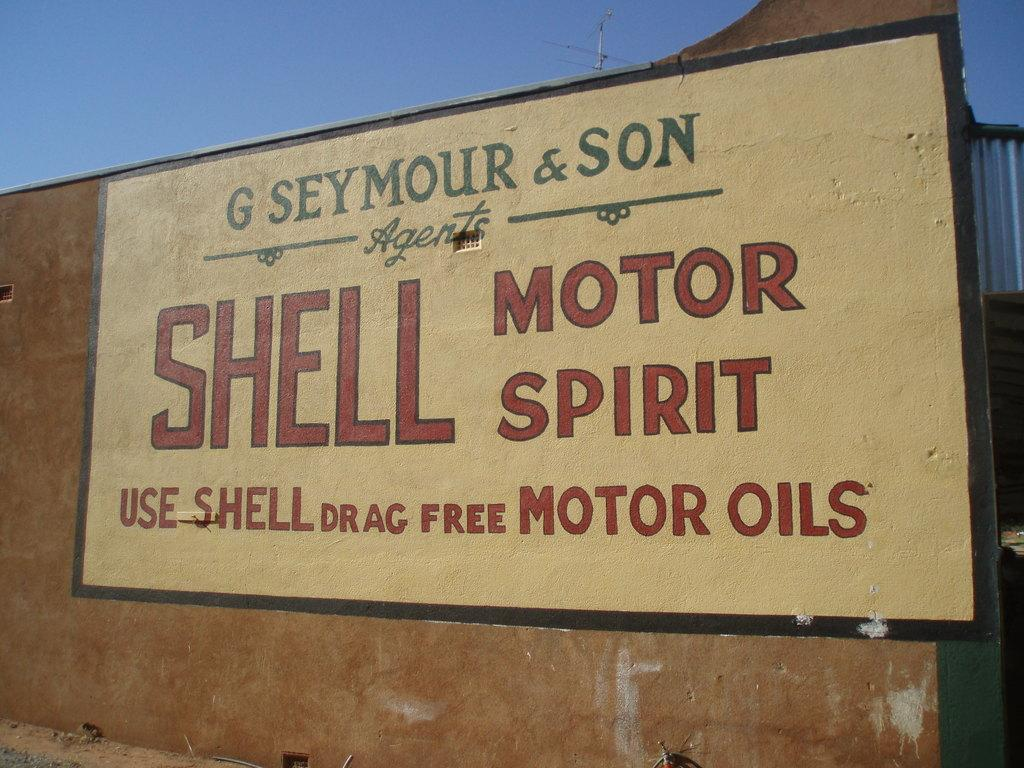<image>
Render a clear and concise summary of the photo. A sign advertiseing Shell drag free motor oils. 